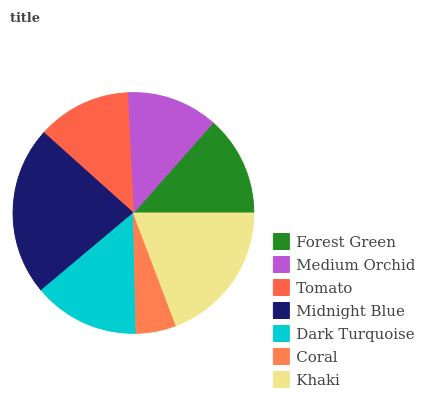Is Coral the minimum?
Answer yes or no. Yes. Is Midnight Blue the maximum?
Answer yes or no. Yes. Is Medium Orchid the minimum?
Answer yes or no. No. Is Medium Orchid the maximum?
Answer yes or no. No. Is Forest Green greater than Medium Orchid?
Answer yes or no. Yes. Is Medium Orchid less than Forest Green?
Answer yes or no. Yes. Is Medium Orchid greater than Forest Green?
Answer yes or no. No. Is Forest Green less than Medium Orchid?
Answer yes or no. No. Is Forest Green the high median?
Answer yes or no. Yes. Is Forest Green the low median?
Answer yes or no. Yes. Is Coral the high median?
Answer yes or no. No. Is Medium Orchid the low median?
Answer yes or no. No. 